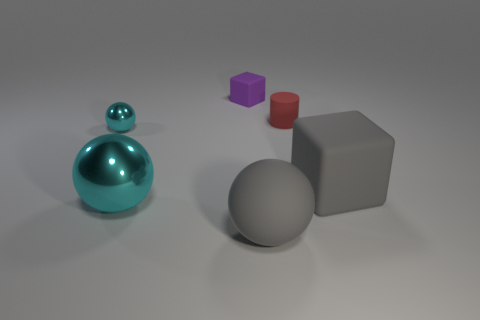What is the shape of the tiny thing that is on the right side of the tiny purple cube to the left of the big gray rubber sphere?
Provide a succinct answer. Cylinder. There is a big sphere that is on the right side of the large cyan metal sphere; is it the same color as the block that is to the left of the gray ball?
Offer a terse response. No. Are there any other things that are the same color as the big metallic object?
Give a very brief answer. Yes. What is the color of the tiny cylinder?
Offer a very short reply. Red. Are there any large balls?
Your answer should be very brief. Yes. Are there any small metallic objects in front of the small cyan sphere?
Give a very brief answer. No. What is the material of the large gray thing that is the same shape as the small metal object?
Provide a succinct answer. Rubber. Is there any other thing that has the same material as the small sphere?
Provide a short and direct response. Yes. What number of other objects are the same shape as the large metal thing?
Make the answer very short. 2. There is a small cyan metal ball that is on the left side of the cube behind the tiny ball; what number of gray objects are left of it?
Keep it short and to the point. 0. 